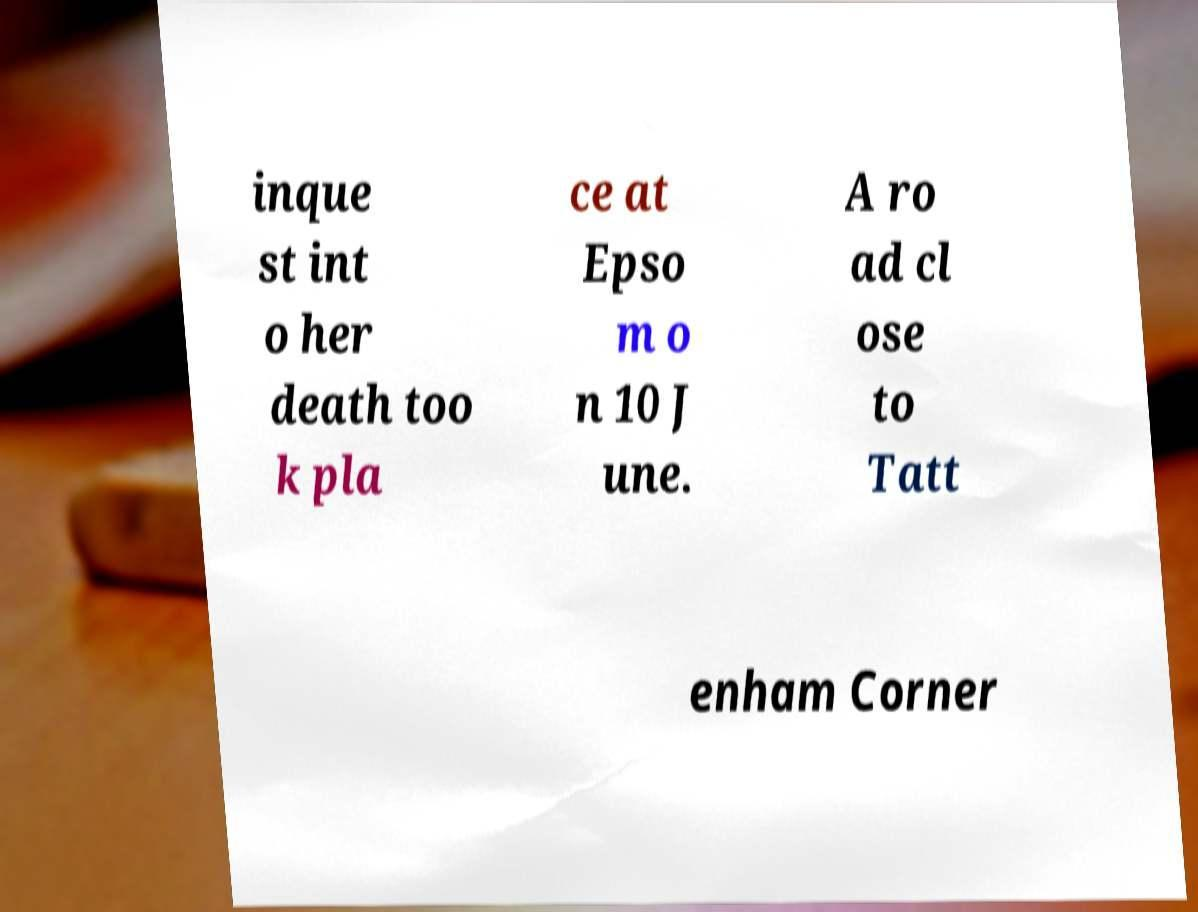There's text embedded in this image that I need extracted. Can you transcribe it verbatim? inque st int o her death too k pla ce at Epso m o n 10 J une. A ro ad cl ose to Tatt enham Corner 